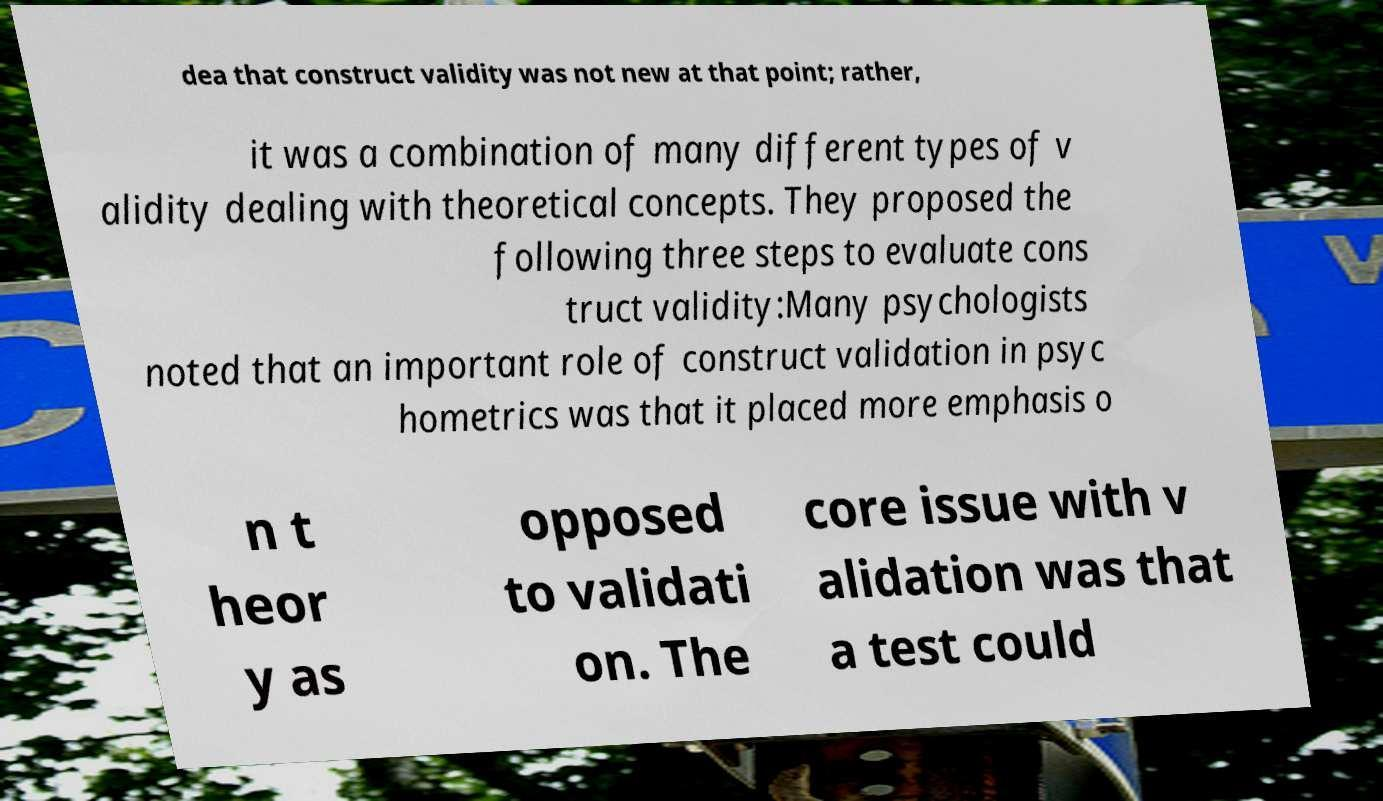Can you accurately transcribe the text from the provided image for me? dea that construct validity was not new at that point; rather, it was a combination of many different types of v alidity dealing with theoretical concepts. They proposed the following three steps to evaluate cons truct validity:Many psychologists noted that an important role of construct validation in psyc hometrics was that it placed more emphasis o n t heor y as opposed to validati on. The core issue with v alidation was that a test could 